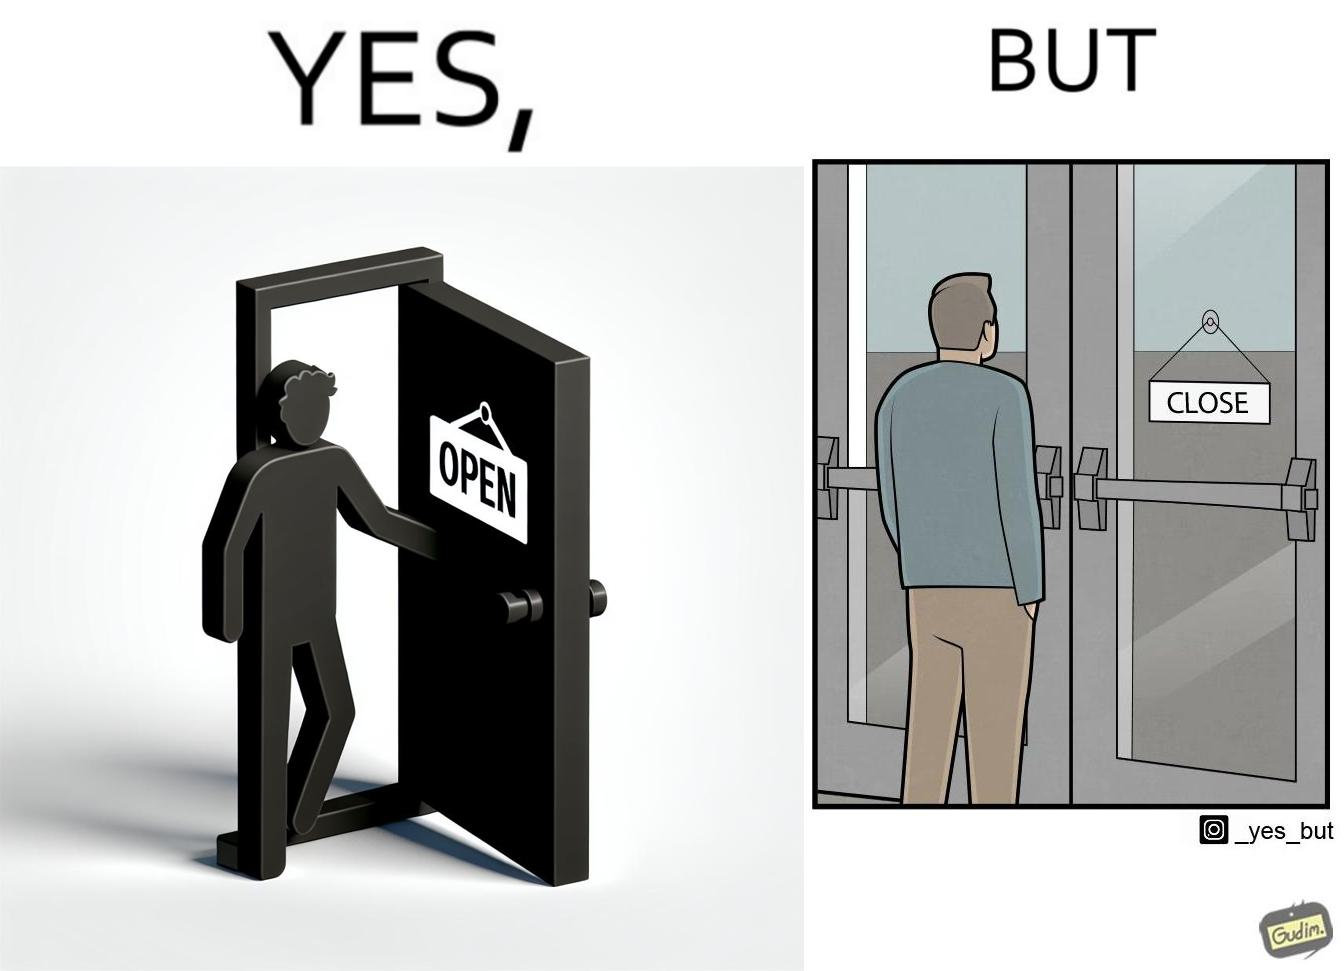Is this image satirical or non-satirical? Yes, this image is satirical. 